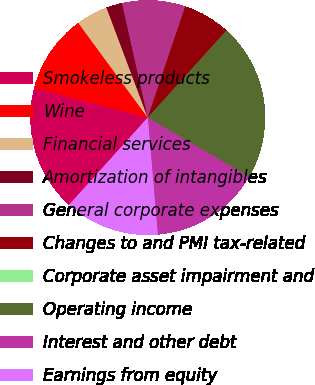<chart> <loc_0><loc_0><loc_500><loc_500><pie_chart><fcel>Smokeless products<fcel>Wine<fcel>Financial services<fcel>Amortization of intangibles<fcel>General corporate expenses<fcel>Changes to and PMI tax-related<fcel>Corporate asset impairment and<fcel>Operating income<fcel>Interest and other debt<fcel>Earnings from equity<nl><fcel>17.38%<fcel>10.87%<fcel>4.36%<fcel>2.19%<fcel>8.7%<fcel>6.53%<fcel>0.02%<fcel>21.71%<fcel>15.21%<fcel>13.04%<nl></chart> 